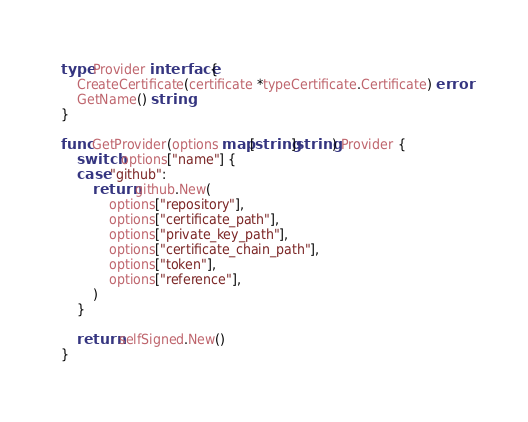Convert code to text. <code><loc_0><loc_0><loc_500><loc_500><_Go_>
type Provider interface {
	CreateCertificate(certificate *typeCertificate.Certificate) error
	GetName() string
}

func GetProvider(options map[string]string) Provider {
	switch options["name"] {
	case "github":
		return github.New(
			options["repository"],
			options["certificate_path"],
			options["private_key_path"],
			options["certificate_chain_path"],
			options["token"],
			options["reference"],
		)
	}

	return selfSigned.New()
}
</code> 